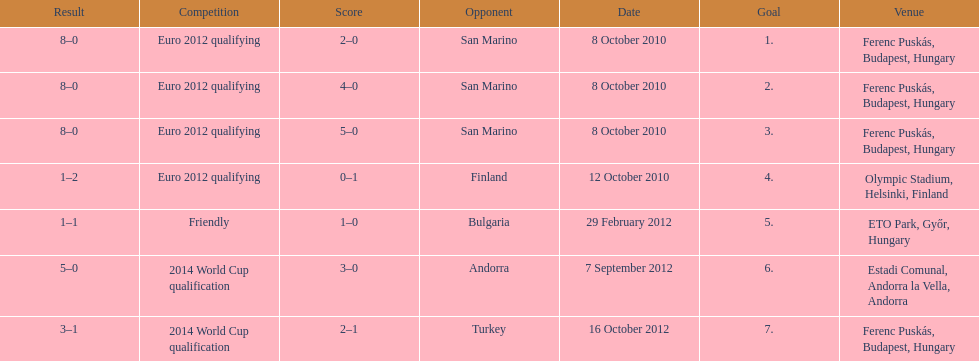How many games did he score but his team lost? 1. 